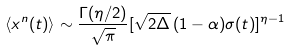<formula> <loc_0><loc_0><loc_500><loc_500>\langle x ^ { n } ( t ) \rangle \sim \frac { \Gamma ( \eta / 2 ) } { \sqrt { \pi } } [ \sqrt { 2 \Delta } \, ( 1 - \alpha ) \sigma ( t ) ] ^ { \eta - 1 }</formula> 